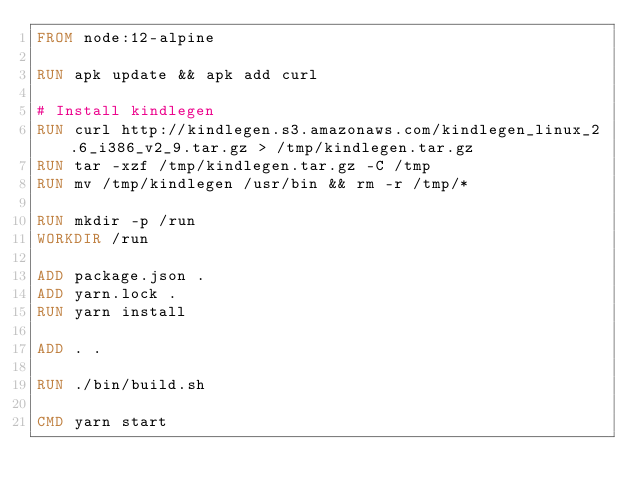Convert code to text. <code><loc_0><loc_0><loc_500><loc_500><_Dockerfile_>FROM node:12-alpine

RUN apk update && apk add curl

# Install kindlegen
RUN curl http://kindlegen.s3.amazonaws.com/kindlegen_linux_2.6_i386_v2_9.tar.gz > /tmp/kindlegen.tar.gz
RUN tar -xzf /tmp/kindlegen.tar.gz -C /tmp
RUN mv /tmp/kindlegen /usr/bin && rm -r /tmp/*

RUN mkdir -p /run
WORKDIR /run

ADD package.json .
ADD yarn.lock .
RUN yarn install

ADD . .

RUN ./bin/build.sh

CMD yarn start
</code> 